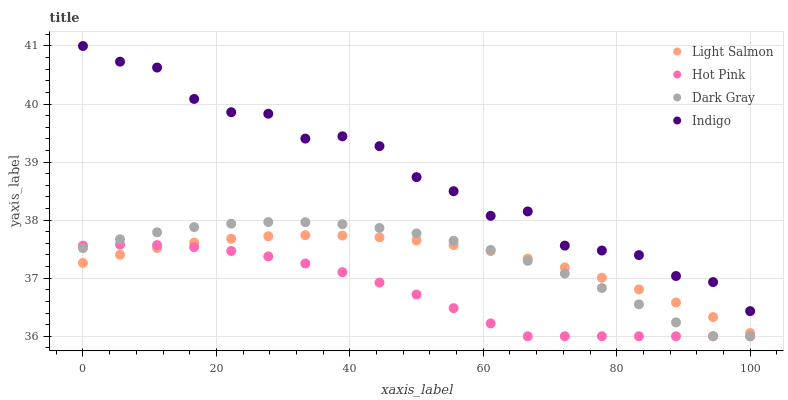Does Hot Pink have the minimum area under the curve?
Answer yes or no. Yes. Does Indigo have the maximum area under the curve?
Answer yes or no. Yes. Does Light Salmon have the minimum area under the curve?
Answer yes or no. No. Does Light Salmon have the maximum area under the curve?
Answer yes or no. No. Is Light Salmon the smoothest?
Answer yes or no. Yes. Is Indigo the roughest?
Answer yes or no. Yes. Is Hot Pink the smoothest?
Answer yes or no. No. Is Hot Pink the roughest?
Answer yes or no. No. Does Dark Gray have the lowest value?
Answer yes or no. Yes. Does Light Salmon have the lowest value?
Answer yes or no. No. Does Indigo have the highest value?
Answer yes or no. Yes. Does Light Salmon have the highest value?
Answer yes or no. No. Is Hot Pink less than Indigo?
Answer yes or no. Yes. Is Indigo greater than Light Salmon?
Answer yes or no. Yes. Does Hot Pink intersect Dark Gray?
Answer yes or no. Yes. Is Hot Pink less than Dark Gray?
Answer yes or no. No. Is Hot Pink greater than Dark Gray?
Answer yes or no. No. Does Hot Pink intersect Indigo?
Answer yes or no. No. 